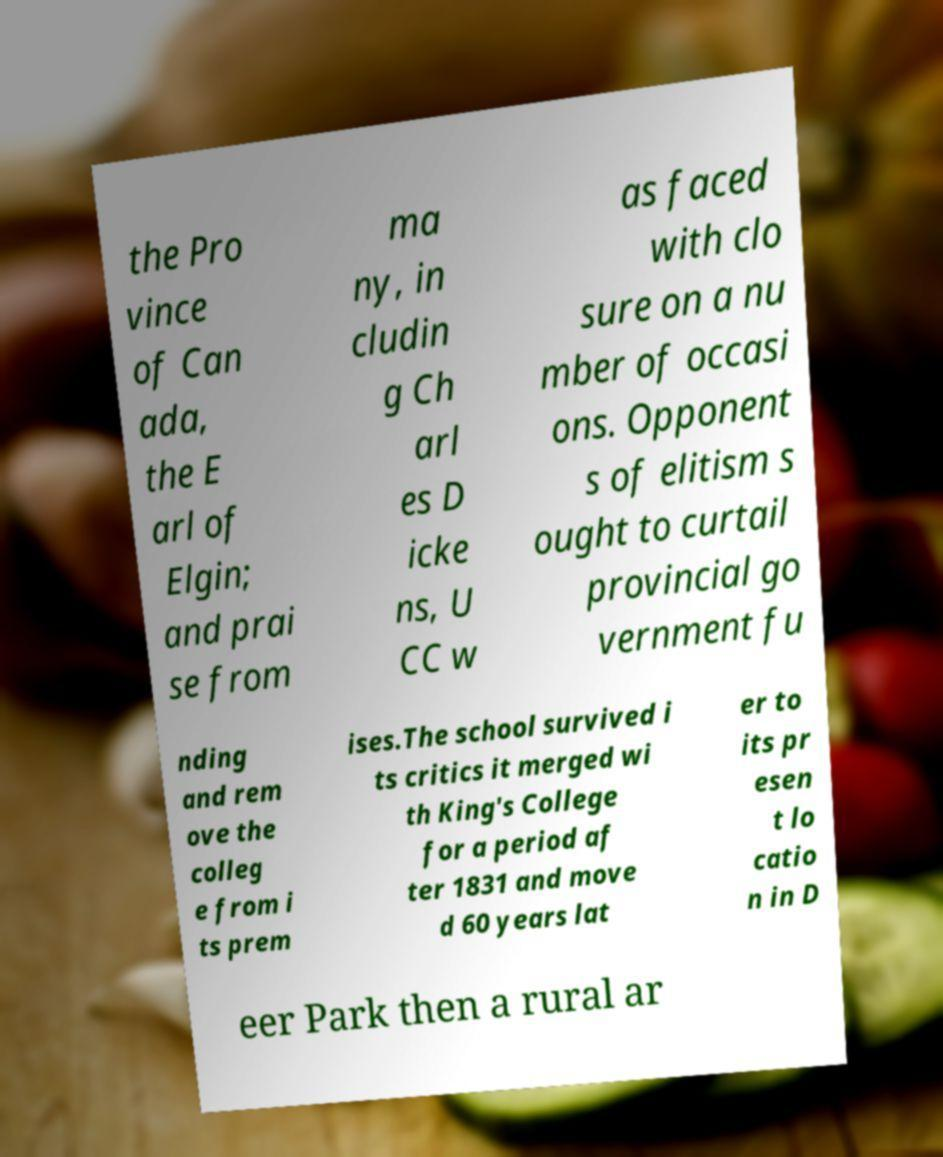What messages or text are displayed in this image? I need them in a readable, typed format. the Pro vince of Can ada, the E arl of Elgin; and prai se from ma ny, in cludin g Ch arl es D icke ns, U CC w as faced with clo sure on a nu mber of occasi ons. Opponent s of elitism s ought to curtail provincial go vernment fu nding and rem ove the colleg e from i ts prem ises.The school survived i ts critics it merged wi th King's College for a period af ter 1831 and move d 60 years lat er to its pr esen t lo catio n in D eer Park then a rural ar 